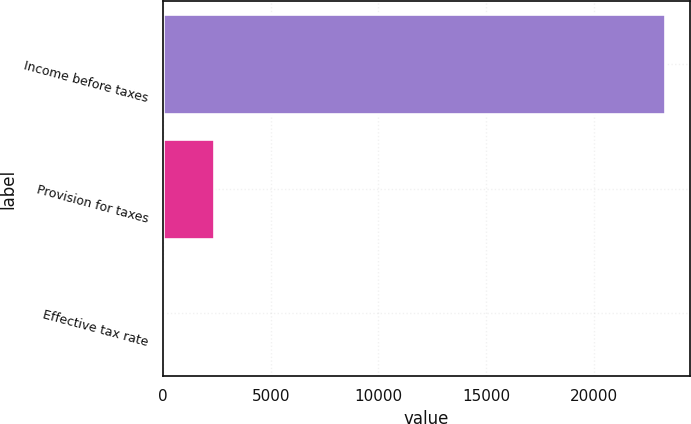<chart> <loc_0><loc_0><loc_500><loc_500><bar_chart><fcel>Income before taxes<fcel>Provision for taxes<fcel>Effective tax rate<nl><fcel>23317<fcel>2340.43<fcel>9.7<nl></chart> 